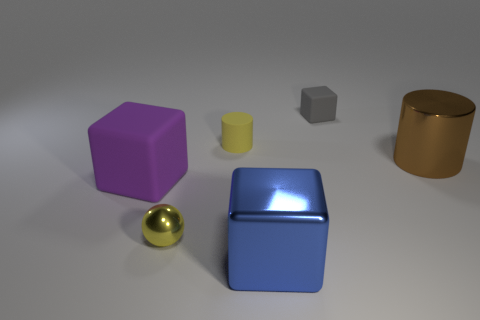What number of other objects are the same color as the small block?
Provide a short and direct response. 0. Is the number of blue cubes that are behind the blue object greater than the number of tiny gray matte objects in front of the metallic cylinder?
Ensure brevity in your answer.  No. Are there any other things that have the same size as the metal cylinder?
Offer a very short reply. Yes. How many cubes are either tiny metal things or purple metal objects?
Offer a terse response. 0. How many things are small yellow objects that are behind the big purple rubber thing or shiny blocks?
Your answer should be very brief. 2. The small yellow object in front of the matte block that is in front of the matte object that is right of the large blue cube is what shape?
Keep it short and to the point. Sphere. What number of big brown metal things have the same shape as the gray matte thing?
Make the answer very short. 0. There is a small sphere that is the same color as the small matte cylinder; what is it made of?
Provide a short and direct response. Metal. Does the small gray cube have the same material as the blue block?
Make the answer very short. No. What number of tiny shiny things are behind the matte cube behind the big block that is behind the small sphere?
Your answer should be compact. 0. 